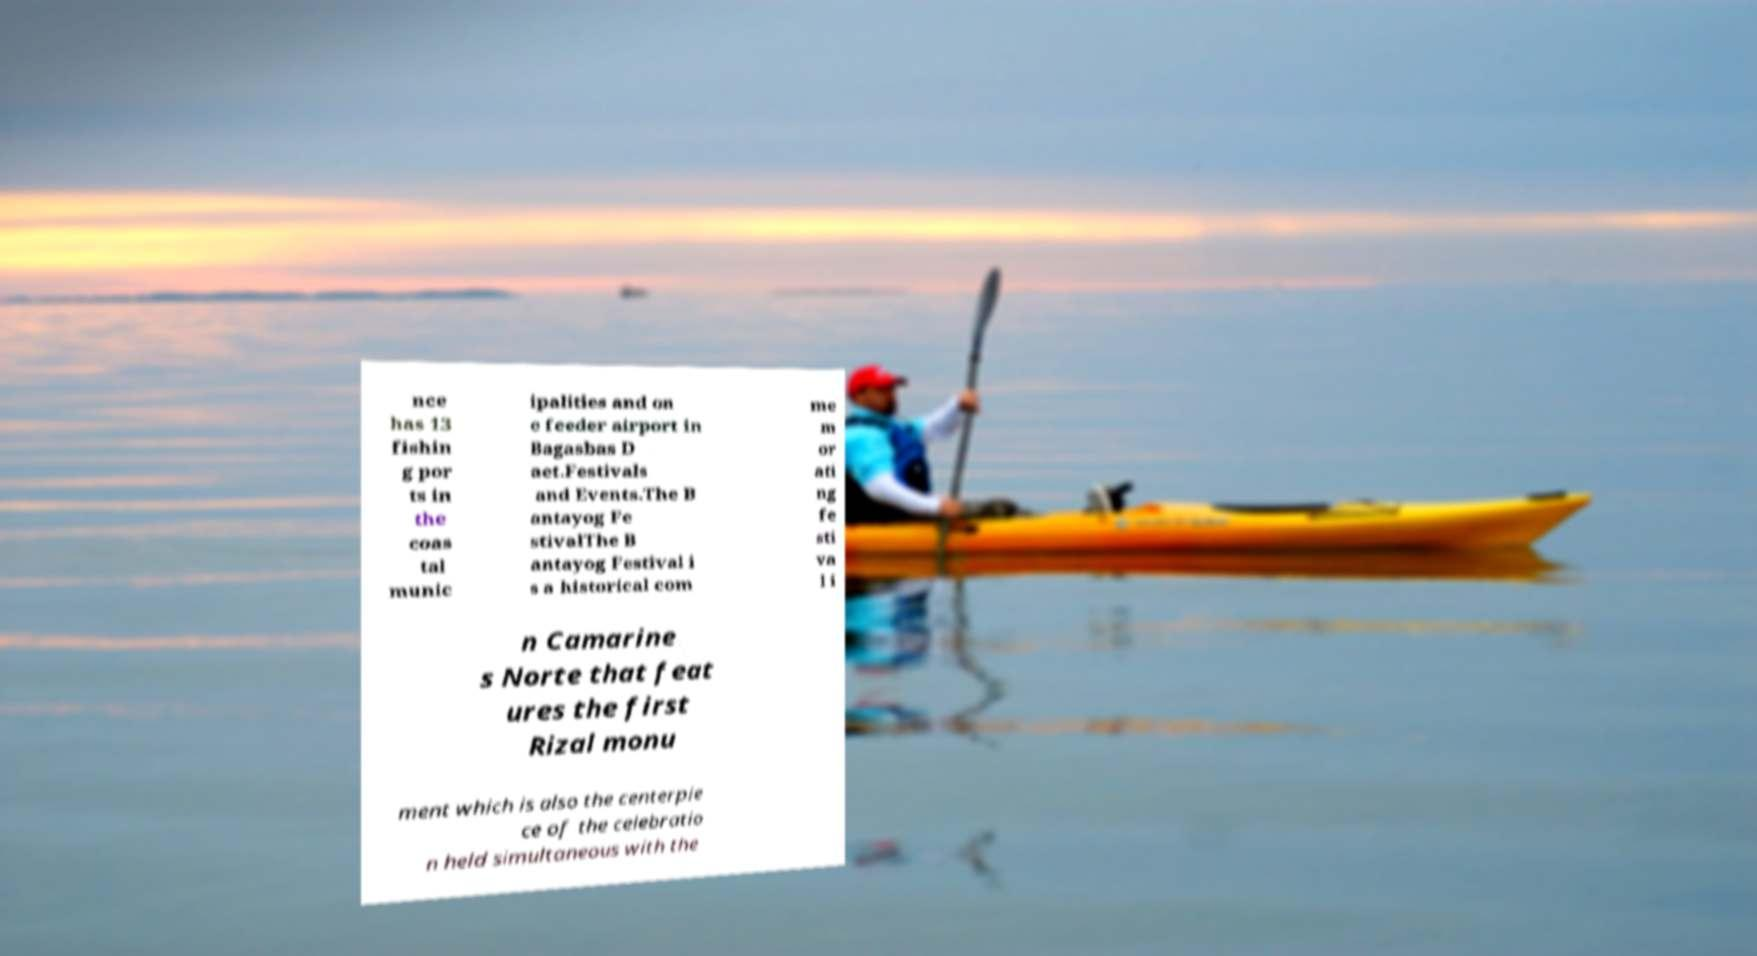Could you assist in decoding the text presented in this image and type it out clearly? nce has 13 fishin g por ts in the coas tal munic ipalities and on e feeder airport in Bagasbas D aet.Festivals and Events.The B antayog Fe stivalThe B antayog Festival i s a historical com me m or ati ng fe sti va l i n Camarine s Norte that feat ures the first Rizal monu ment which is also the centerpie ce of the celebratio n held simultaneous with the 